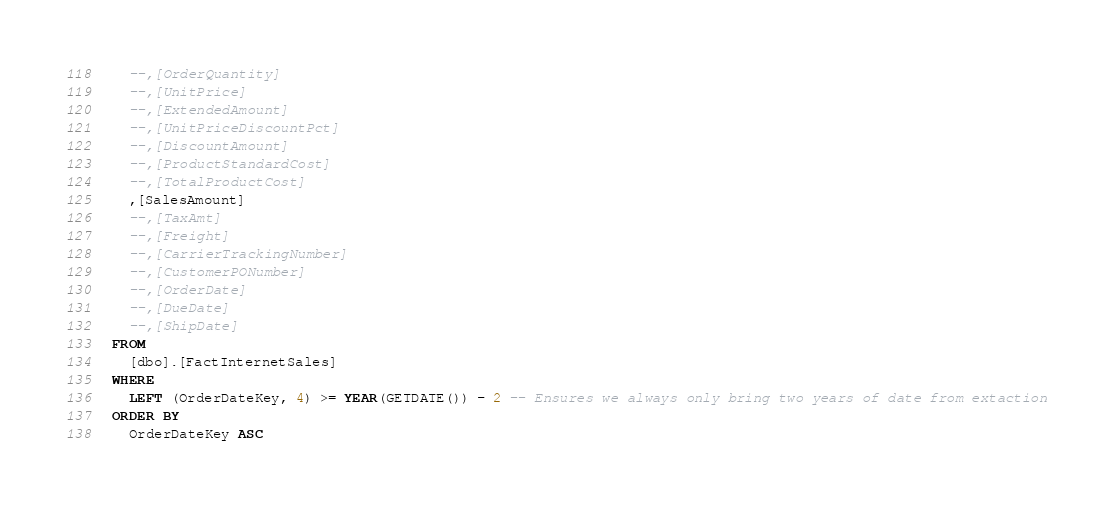<code> <loc_0><loc_0><loc_500><loc_500><_SQL_>	--,[OrderQuantity]
	--,[UnitPrice]
	--,[ExtendedAmount]
	--,[UnitPriceDiscountPct]
	--,[DiscountAmount]
	--,[ProductStandardCost]
	--,[TotalProductCost]
	,[SalesAmount]
	--,[TaxAmt]
	--,[Freight]
	--,[CarrierTrackingNumber]
	--,[CustomerPONumber]
	--,[OrderDate]
	--,[DueDate]
	--,[ShipDate]
  FROM 
	[dbo].[FactInternetSales]
  WHERE
	LEFT (OrderDateKey, 4) >= YEAR(GETDATE()) - 2 -- Ensures we always only bring two years of date from extaction
  ORDER BY 
	OrderDateKey ASC</code> 